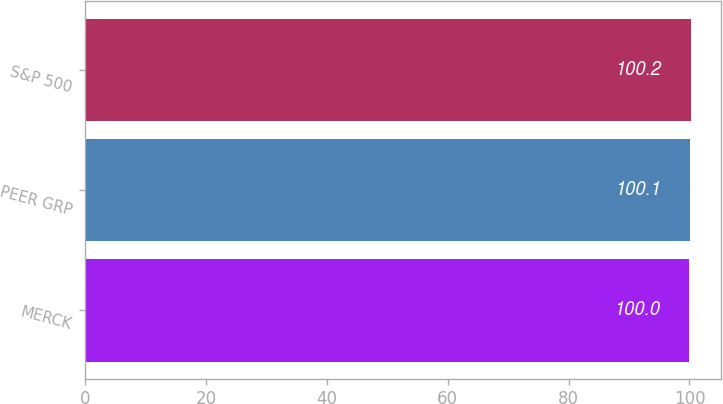<chart> <loc_0><loc_0><loc_500><loc_500><bar_chart><fcel>MERCK<fcel>PEER GRP<fcel>S&P 500<nl><fcel>100<fcel>100.1<fcel>100.2<nl></chart> 